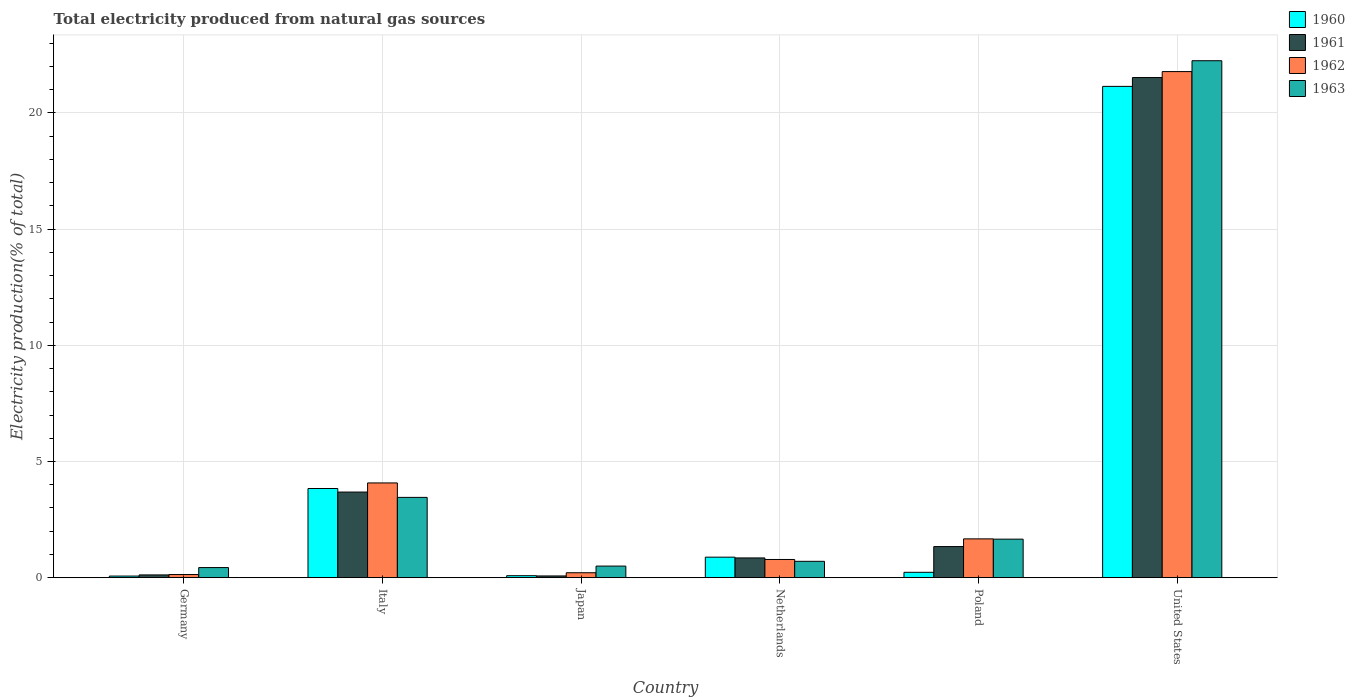How many different coloured bars are there?
Your answer should be compact. 4. Are the number of bars per tick equal to the number of legend labels?
Provide a short and direct response. Yes. Are the number of bars on each tick of the X-axis equal?
Offer a very short reply. Yes. How many bars are there on the 4th tick from the right?
Offer a very short reply. 4. In how many cases, is the number of bars for a given country not equal to the number of legend labels?
Your answer should be compact. 0. What is the total electricity produced in 1961 in Netherlands?
Offer a terse response. 0.85. Across all countries, what is the maximum total electricity produced in 1961?
Your answer should be compact. 21.52. Across all countries, what is the minimum total electricity produced in 1962?
Provide a succinct answer. 0.14. What is the total total electricity produced in 1960 in the graph?
Offer a very short reply. 26.25. What is the difference between the total electricity produced in 1962 in Italy and that in United States?
Ensure brevity in your answer.  -17.7. What is the difference between the total electricity produced in 1960 in Netherlands and the total electricity produced in 1961 in Japan?
Ensure brevity in your answer.  0.81. What is the average total electricity produced in 1963 per country?
Your answer should be compact. 4.83. What is the difference between the total electricity produced of/in 1962 and total electricity produced of/in 1961 in Italy?
Your answer should be compact. 0.39. What is the ratio of the total electricity produced in 1961 in Netherlands to that in Poland?
Offer a terse response. 0.64. Is the total electricity produced in 1963 in Japan less than that in United States?
Make the answer very short. Yes. Is the difference between the total electricity produced in 1962 in Germany and Poland greater than the difference between the total electricity produced in 1961 in Germany and Poland?
Your response must be concise. No. What is the difference between the highest and the second highest total electricity produced in 1962?
Ensure brevity in your answer.  -2.41. What is the difference between the highest and the lowest total electricity produced in 1960?
Your response must be concise. 21.07. What does the 3rd bar from the right in Italy represents?
Make the answer very short. 1961. Is it the case that in every country, the sum of the total electricity produced in 1963 and total electricity produced in 1962 is greater than the total electricity produced in 1961?
Provide a short and direct response. Yes. How many bars are there?
Give a very brief answer. 24. Does the graph contain any zero values?
Offer a terse response. No. How are the legend labels stacked?
Provide a succinct answer. Vertical. What is the title of the graph?
Provide a short and direct response. Total electricity produced from natural gas sources. What is the label or title of the X-axis?
Make the answer very short. Country. What is the label or title of the Y-axis?
Your response must be concise. Electricity production(% of total). What is the Electricity production(% of total) of 1960 in Germany?
Provide a short and direct response. 0.07. What is the Electricity production(% of total) in 1961 in Germany?
Provide a short and direct response. 0.12. What is the Electricity production(% of total) in 1962 in Germany?
Ensure brevity in your answer.  0.14. What is the Electricity production(% of total) in 1963 in Germany?
Your answer should be very brief. 0.44. What is the Electricity production(% of total) of 1960 in Italy?
Offer a very short reply. 3.84. What is the Electricity production(% of total) in 1961 in Italy?
Provide a succinct answer. 3.69. What is the Electricity production(% of total) in 1962 in Italy?
Provide a succinct answer. 4.08. What is the Electricity production(% of total) in 1963 in Italy?
Ensure brevity in your answer.  3.46. What is the Electricity production(% of total) in 1960 in Japan?
Provide a short and direct response. 0.09. What is the Electricity production(% of total) of 1961 in Japan?
Ensure brevity in your answer.  0.08. What is the Electricity production(% of total) in 1962 in Japan?
Your response must be concise. 0.21. What is the Electricity production(% of total) in 1963 in Japan?
Keep it short and to the point. 0.5. What is the Electricity production(% of total) of 1960 in Netherlands?
Make the answer very short. 0.88. What is the Electricity production(% of total) of 1961 in Netherlands?
Your answer should be compact. 0.85. What is the Electricity production(% of total) of 1962 in Netherlands?
Offer a terse response. 0.78. What is the Electricity production(% of total) of 1963 in Netherlands?
Keep it short and to the point. 0.71. What is the Electricity production(% of total) in 1960 in Poland?
Give a very brief answer. 0.23. What is the Electricity production(% of total) in 1961 in Poland?
Provide a succinct answer. 1.34. What is the Electricity production(% of total) of 1962 in Poland?
Offer a very short reply. 1.67. What is the Electricity production(% of total) of 1963 in Poland?
Your response must be concise. 1.66. What is the Electricity production(% of total) in 1960 in United States?
Give a very brief answer. 21.14. What is the Electricity production(% of total) of 1961 in United States?
Your answer should be very brief. 21.52. What is the Electricity production(% of total) in 1962 in United States?
Keep it short and to the point. 21.78. What is the Electricity production(% of total) in 1963 in United States?
Offer a terse response. 22.24. Across all countries, what is the maximum Electricity production(% of total) in 1960?
Your answer should be compact. 21.14. Across all countries, what is the maximum Electricity production(% of total) of 1961?
Offer a terse response. 21.52. Across all countries, what is the maximum Electricity production(% of total) of 1962?
Provide a succinct answer. 21.78. Across all countries, what is the maximum Electricity production(% of total) of 1963?
Ensure brevity in your answer.  22.24. Across all countries, what is the minimum Electricity production(% of total) in 1960?
Make the answer very short. 0.07. Across all countries, what is the minimum Electricity production(% of total) of 1961?
Give a very brief answer. 0.08. Across all countries, what is the minimum Electricity production(% of total) in 1962?
Provide a short and direct response. 0.14. Across all countries, what is the minimum Electricity production(% of total) in 1963?
Your response must be concise. 0.44. What is the total Electricity production(% of total) of 1960 in the graph?
Your answer should be very brief. 26.25. What is the total Electricity production(% of total) of 1961 in the graph?
Your response must be concise. 27.59. What is the total Electricity production(% of total) in 1962 in the graph?
Ensure brevity in your answer.  28.66. What is the total Electricity production(% of total) in 1963 in the graph?
Give a very brief answer. 29. What is the difference between the Electricity production(% of total) in 1960 in Germany and that in Italy?
Ensure brevity in your answer.  -3.77. What is the difference between the Electricity production(% of total) of 1961 in Germany and that in Italy?
Your response must be concise. -3.57. What is the difference between the Electricity production(% of total) in 1962 in Germany and that in Italy?
Keep it short and to the point. -3.94. What is the difference between the Electricity production(% of total) of 1963 in Germany and that in Italy?
Provide a succinct answer. -3.02. What is the difference between the Electricity production(% of total) in 1960 in Germany and that in Japan?
Your answer should be very brief. -0.02. What is the difference between the Electricity production(% of total) in 1961 in Germany and that in Japan?
Your answer should be very brief. 0.04. What is the difference between the Electricity production(% of total) in 1962 in Germany and that in Japan?
Keep it short and to the point. -0.08. What is the difference between the Electricity production(% of total) in 1963 in Germany and that in Japan?
Your answer should be very brief. -0.06. What is the difference between the Electricity production(% of total) of 1960 in Germany and that in Netherlands?
Your answer should be compact. -0.81. What is the difference between the Electricity production(% of total) of 1961 in Germany and that in Netherlands?
Your response must be concise. -0.73. What is the difference between the Electricity production(% of total) of 1962 in Germany and that in Netherlands?
Ensure brevity in your answer.  -0.65. What is the difference between the Electricity production(% of total) of 1963 in Germany and that in Netherlands?
Give a very brief answer. -0.27. What is the difference between the Electricity production(% of total) of 1960 in Germany and that in Poland?
Keep it short and to the point. -0.16. What is the difference between the Electricity production(% of total) in 1961 in Germany and that in Poland?
Provide a succinct answer. -1.22. What is the difference between the Electricity production(% of total) of 1962 in Germany and that in Poland?
Make the answer very short. -1.53. What is the difference between the Electricity production(% of total) of 1963 in Germany and that in Poland?
Give a very brief answer. -1.22. What is the difference between the Electricity production(% of total) in 1960 in Germany and that in United States?
Your answer should be very brief. -21.07. What is the difference between the Electricity production(% of total) of 1961 in Germany and that in United States?
Your response must be concise. -21.4. What is the difference between the Electricity production(% of total) in 1962 in Germany and that in United States?
Ensure brevity in your answer.  -21.64. What is the difference between the Electricity production(% of total) in 1963 in Germany and that in United States?
Offer a very short reply. -21.81. What is the difference between the Electricity production(% of total) in 1960 in Italy and that in Japan?
Your answer should be very brief. 3.75. What is the difference between the Electricity production(% of total) in 1961 in Italy and that in Japan?
Provide a succinct answer. 3.61. What is the difference between the Electricity production(% of total) of 1962 in Italy and that in Japan?
Keep it short and to the point. 3.86. What is the difference between the Electricity production(% of total) in 1963 in Italy and that in Japan?
Your response must be concise. 2.96. What is the difference between the Electricity production(% of total) of 1960 in Italy and that in Netherlands?
Ensure brevity in your answer.  2.95. What is the difference between the Electricity production(% of total) in 1961 in Italy and that in Netherlands?
Your answer should be compact. 2.83. What is the difference between the Electricity production(% of total) in 1962 in Italy and that in Netherlands?
Your answer should be very brief. 3.29. What is the difference between the Electricity production(% of total) of 1963 in Italy and that in Netherlands?
Your answer should be compact. 2.75. What is the difference between the Electricity production(% of total) of 1960 in Italy and that in Poland?
Provide a short and direct response. 3.61. What is the difference between the Electricity production(% of total) in 1961 in Italy and that in Poland?
Give a very brief answer. 2.35. What is the difference between the Electricity production(% of total) in 1962 in Italy and that in Poland?
Your answer should be compact. 2.41. What is the difference between the Electricity production(% of total) of 1963 in Italy and that in Poland?
Your response must be concise. 1.8. What is the difference between the Electricity production(% of total) of 1960 in Italy and that in United States?
Keep it short and to the point. -17.3. What is the difference between the Electricity production(% of total) in 1961 in Italy and that in United States?
Your response must be concise. -17.84. What is the difference between the Electricity production(% of total) in 1962 in Italy and that in United States?
Offer a terse response. -17.7. What is the difference between the Electricity production(% of total) in 1963 in Italy and that in United States?
Offer a very short reply. -18.79. What is the difference between the Electricity production(% of total) in 1960 in Japan and that in Netherlands?
Provide a short and direct response. -0.8. What is the difference between the Electricity production(% of total) in 1961 in Japan and that in Netherlands?
Provide a short and direct response. -0.78. What is the difference between the Electricity production(% of total) in 1962 in Japan and that in Netherlands?
Provide a succinct answer. -0.57. What is the difference between the Electricity production(% of total) in 1963 in Japan and that in Netherlands?
Make the answer very short. -0.21. What is the difference between the Electricity production(% of total) in 1960 in Japan and that in Poland?
Keep it short and to the point. -0.15. What is the difference between the Electricity production(% of total) in 1961 in Japan and that in Poland?
Provide a succinct answer. -1.26. What is the difference between the Electricity production(% of total) of 1962 in Japan and that in Poland?
Your response must be concise. -1.46. What is the difference between the Electricity production(% of total) of 1963 in Japan and that in Poland?
Your answer should be very brief. -1.16. What is the difference between the Electricity production(% of total) in 1960 in Japan and that in United States?
Keep it short and to the point. -21.05. What is the difference between the Electricity production(% of total) in 1961 in Japan and that in United States?
Ensure brevity in your answer.  -21.45. What is the difference between the Electricity production(% of total) of 1962 in Japan and that in United States?
Provide a succinct answer. -21.56. What is the difference between the Electricity production(% of total) in 1963 in Japan and that in United States?
Offer a very short reply. -21.74. What is the difference between the Electricity production(% of total) of 1960 in Netherlands and that in Poland?
Ensure brevity in your answer.  0.65. What is the difference between the Electricity production(% of total) of 1961 in Netherlands and that in Poland?
Offer a terse response. -0.49. What is the difference between the Electricity production(% of total) of 1962 in Netherlands and that in Poland?
Offer a terse response. -0.89. What is the difference between the Electricity production(% of total) of 1963 in Netherlands and that in Poland?
Provide a succinct answer. -0.95. What is the difference between the Electricity production(% of total) of 1960 in Netherlands and that in United States?
Provide a succinct answer. -20.26. What is the difference between the Electricity production(% of total) in 1961 in Netherlands and that in United States?
Provide a succinct answer. -20.67. What is the difference between the Electricity production(% of total) of 1962 in Netherlands and that in United States?
Ensure brevity in your answer.  -20.99. What is the difference between the Electricity production(% of total) in 1963 in Netherlands and that in United States?
Offer a terse response. -21.54. What is the difference between the Electricity production(% of total) in 1960 in Poland and that in United States?
Offer a terse response. -20.91. What is the difference between the Electricity production(% of total) of 1961 in Poland and that in United States?
Give a very brief answer. -20.18. What is the difference between the Electricity production(% of total) of 1962 in Poland and that in United States?
Offer a very short reply. -20.11. What is the difference between the Electricity production(% of total) of 1963 in Poland and that in United States?
Your answer should be compact. -20.59. What is the difference between the Electricity production(% of total) of 1960 in Germany and the Electricity production(% of total) of 1961 in Italy?
Your response must be concise. -3.62. What is the difference between the Electricity production(% of total) of 1960 in Germany and the Electricity production(% of total) of 1962 in Italy?
Offer a very short reply. -4.01. What is the difference between the Electricity production(% of total) in 1960 in Germany and the Electricity production(% of total) in 1963 in Italy?
Your answer should be very brief. -3.39. What is the difference between the Electricity production(% of total) in 1961 in Germany and the Electricity production(% of total) in 1962 in Italy?
Offer a very short reply. -3.96. What is the difference between the Electricity production(% of total) of 1961 in Germany and the Electricity production(% of total) of 1963 in Italy?
Ensure brevity in your answer.  -3.34. What is the difference between the Electricity production(% of total) in 1962 in Germany and the Electricity production(% of total) in 1963 in Italy?
Keep it short and to the point. -3.32. What is the difference between the Electricity production(% of total) in 1960 in Germany and the Electricity production(% of total) in 1961 in Japan?
Ensure brevity in your answer.  -0.01. What is the difference between the Electricity production(% of total) of 1960 in Germany and the Electricity production(% of total) of 1962 in Japan?
Keep it short and to the point. -0.14. What is the difference between the Electricity production(% of total) of 1960 in Germany and the Electricity production(% of total) of 1963 in Japan?
Keep it short and to the point. -0.43. What is the difference between the Electricity production(% of total) in 1961 in Germany and the Electricity production(% of total) in 1962 in Japan?
Give a very brief answer. -0.09. What is the difference between the Electricity production(% of total) of 1961 in Germany and the Electricity production(% of total) of 1963 in Japan?
Offer a terse response. -0.38. What is the difference between the Electricity production(% of total) of 1962 in Germany and the Electricity production(% of total) of 1963 in Japan?
Keep it short and to the point. -0.36. What is the difference between the Electricity production(% of total) in 1960 in Germany and the Electricity production(% of total) in 1961 in Netherlands?
Ensure brevity in your answer.  -0.78. What is the difference between the Electricity production(% of total) in 1960 in Germany and the Electricity production(% of total) in 1962 in Netherlands?
Offer a terse response. -0.71. What is the difference between the Electricity production(% of total) in 1960 in Germany and the Electricity production(% of total) in 1963 in Netherlands?
Offer a terse response. -0.64. What is the difference between the Electricity production(% of total) of 1961 in Germany and the Electricity production(% of total) of 1962 in Netherlands?
Give a very brief answer. -0.66. What is the difference between the Electricity production(% of total) in 1961 in Germany and the Electricity production(% of total) in 1963 in Netherlands?
Your answer should be compact. -0.58. What is the difference between the Electricity production(% of total) in 1962 in Germany and the Electricity production(% of total) in 1963 in Netherlands?
Ensure brevity in your answer.  -0.57. What is the difference between the Electricity production(% of total) of 1960 in Germany and the Electricity production(% of total) of 1961 in Poland?
Provide a succinct answer. -1.27. What is the difference between the Electricity production(% of total) of 1960 in Germany and the Electricity production(% of total) of 1962 in Poland?
Your answer should be compact. -1.6. What is the difference between the Electricity production(% of total) of 1960 in Germany and the Electricity production(% of total) of 1963 in Poland?
Make the answer very short. -1.59. What is the difference between the Electricity production(% of total) in 1961 in Germany and the Electricity production(% of total) in 1962 in Poland?
Ensure brevity in your answer.  -1.55. What is the difference between the Electricity production(% of total) of 1961 in Germany and the Electricity production(% of total) of 1963 in Poland?
Offer a terse response. -1.54. What is the difference between the Electricity production(% of total) of 1962 in Germany and the Electricity production(% of total) of 1963 in Poland?
Your response must be concise. -1.52. What is the difference between the Electricity production(% of total) of 1960 in Germany and the Electricity production(% of total) of 1961 in United States?
Your answer should be compact. -21.45. What is the difference between the Electricity production(% of total) in 1960 in Germany and the Electricity production(% of total) in 1962 in United States?
Your answer should be very brief. -21.71. What is the difference between the Electricity production(% of total) of 1960 in Germany and the Electricity production(% of total) of 1963 in United States?
Keep it short and to the point. -22.17. What is the difference between the Electricity production(% of total) in 1961 in Germany and the Electricity production(% of total) in 1962 in United States?
Your answer should be very brief. -21.66. What is the difference between the Electricity production(% of total) of 1961 in Germany and the Electricity production(% of total) of 1963 in United States?
Give a very brief answer. -22.12. What is the difference between the Electricity production(% of total) in 1962 in Germany and the Electricity production(% of total) in 1963 in United States?
Keep it short and to the point. -22.11. What is the difference between the Electricity production(% of total) in 1960 in Italy and the Electricity production(% of total) in 1961 in Japan?
Keep it short and to the point. 3.76. What is the difference between the Electricity production(% of total) of 1960 in Italy and the Electricity production(% of total) of 1962 in Japan?
Give a very brief answer. 3.62. What is the difference between the Electricity production(% of total) of 1960 in Italy and the Electricity production(% of total) of 1963 in Japan?
Ensure brevity in your answer.  3.34. What is the difference between the Electricity production(% of total) of 1961 in Italy and the Electricity production(% of total) of 1962 in Japan?
Your response must be concise. 3.47. What is the difference between the Electricity production(% of total) of 1961 in Italy and the Electricity production(% of total) of 1963 in Japan?
Provide a short and direct response. 3.19. What is the difference between the Electricity production(% of total) of 1962 in Italy and the Electricity production(% of total) of 1963 in Japan?
Offer a terse response. 3.58. What is the difference between the Electricity production(% of total) in 1960 in Italy and the Electricity production(% of total) in 1961 in Netherlands?
Keep it short and to the point. 2.99. What is the difference between the Electricity production(% of total) of 1960 in Italy and the Electricity production(% of total) of 1962 in Netherlands?
Your answer should be very brief. 3.05. What is the difference between the Electricity production(% of total) of 1960 in Italy and the Electricity production(% of total) of 1963 in Netherlands?
Make the answer very short. 3.13. What is the difference between the Electricity production(% of total) of 1961 in Italy and the Electricity production(% of total) of 1962 in Netherlands?
Keep it short and to the point. 2.9. What is the difference between the Electricity production(% of total) of 1961 in Italy and the Electricity production(% of total) of 1963 in Netherlands?
Your response must be concise. 2.98. What is the difference between the Electricity production(% of total) in 1962 in Italy and the Electricity production(% of total) in 1963 in Netherlands?
Provide a short and direct response. 3.37. What is the difference between the Electricity production(% of total) of 1960 in Italy and the Electricity production(% of total) of 1961 in Poland?
Your answer should be compact. 2.5. What is the difference between the Electricity production(% of total) in 1960 in Italy and the Electricity production(% of total) in 1962 in Poland?
Make the answer very short. 2.17. What is the difference between the Electricity production(% of total) of 1960 in Italy and the Electricity production(% of total) of 1963 in Poland?
Your answer should be very brief. 2.18. What is the difference between the Electricity production(% of total) in 1961 in Italy and the Electricity production(% of total) in 1962 in Poland?
Ensure brevity in your answer.  2.01. What is the difference between the Electricity production(% of total) of 1961 in Italy and the Electricity production(% of total) of 1963 in Poland?
Offer a very short reply. 2.03. What is the difference between the Electricity production(% of total) in 1962 in Italy and the Electricity production(% of total) in 1963 in Poland?
Offer a terse response. 2.42. What is the difference between the Electricity production(% of total) of 1960 in Italy and the Electricity production(% of total) of 1961 in United States?
Your answer should be compact. -17.68. What is the difference between the Electricity production(% of total) of 1960 in Italy and the Electricity production(% of total) of 1962 in United States?
Your answer should be compact. -17.94. What is the difference between the Electricity production(% of total) of 1960 in Italy and the Electricity production(% of total) of 1963 in United States?
Your response must be concise. -18.41. What is the difference between the Electricity production(% of total) of 1961 in Italy and the Electricity production(% of total) of 1962 in United States?
Your answer should be compact. -18.09. What is the difference between the Electricity production(% of total) in 1961 in Italy and the Electricity production(% of total) in 1963 in United States?
Offer a terse response. -18.56. What is the difference between the Electricity production(% of total) of 1962 in Italy and the Electricity production(% of total) of 1963 in United States?
Your answer should be very brief. -18.17. What is the difference between the Electricity production(% of total) of 1960 in Japan and the Electricity production(% of total) of 1961 in Netherlands?
Offer a terse response. -0.76. What is the difference between the Electricity production(% of total) in 1960 in Japan and the Electricity production(% of total) in 1962 in Netherlands?
Your answer should be compact. -0.7. What is the difference between the Electricity production(% of total) in 1960 in Japan and the Electricity production(% of total) in 1963 in Netherlands?
Provide a succinct answer. -0.62. What is the difference between the Electricity production(% of total) of 1961 in Japan and the Electricity production(% of total) of 1962 in Netherlands?
Your response must be concise. -0.71. What is the difference between the Electricity production(% of total) in 1961 in Japan and the Electricity production(% of total) in 1963 in Netherlands?
Keep it short and to the point. -0.63. What is the difference between the Electricity production(% of total) of 1962 in Japan and the Electricity production(% of total) of 1963 in Netherlands?
Provide a short and direct response. -0.49. What is the difference between the Electricity production(% of total) in 1960 in Japan and the Electricity production(% of total) in 1961 in Poland?
Make the answer very short. -1.25. What is the difference between the Electricity production(% of total) in 1960 in Japan and the Electricity production(% of total) in 1962 in Poland?
Your response must be concise. -1.58. What is the difference between the Electricity production(% of total) in 1960 in Japan and the Electricity production(% of total) in 1963 in Poland?
Your answer should be very brief. -1.57. What is the difference between the Electricity production(% of total) of 1961 in Japan and the Electricity production(% of total) of 1962 in Poland?
Keep it short and to the point. -1.6. What is the difference between the Electricity production(% of total) of 1961 in Japan and the Electricity production(% of total) of 1963 in Poland?
Give a very brief answer. -1.58. What is the difference between the Electricity production(% of total) of 1962 in Japan and the Electricity production(% of total) of 1963 in Poland?
Your response must be concise. -1.45. What is the difference between the Electricity production(% of total) of 1960 in Japan and the Electricity production(% of total) of 1961 in United States?
Your answer should be very brief. -21.43. What is the difference between the Electricity production(% of total) of 1960 in Japan and the Electricity production(% of total) of 1962 in United States?
Keep it short and to the point. -21.69. What is the difference between the Electricity production(% of total) in 1960 in Japan and the Electricity production(% of total) in 1963 in United States?
Provide a succinct answer. -22.16. What is the difference between the Electricity production(% of total) of 1961 in Japan and the Electricity production(% of total) of 1962 in United States?
Make the answer very short. -21.7. What is the difference between the Electricity production(% of total) in 1961 in Japan and the Electricity production(% of total) in 1963 in United States?
Your answer should be compact. -22.17. What is the difference between the Electricity production(% of total) of 1962 in Japan and the Electricity production(% of total) of 1963 in United States?
Ensure brevity in your answer.  -22.03. What is the difference between the Electricity production(% of total) of 1960 in Netherlands and the Electricity production(% of total) of 1961 in Poland?
Offer a very short reply. -0.46. What is the difference between the Electricity production(% of total) in 1960 in Netherlands and the Electricity production(% of total) in 1962 in Poland?
Keep it short and to the point. -0.79. What is the difference between the Electricity production(% of total) in 1960 in Netherlands and the Electricity production(% of total) in 1963 in Poland?
Your answer should be very brief. -0.78. What is the difference between the Electricity production(% of total) of 1961 in Netherlands and the Electricity production(% of total) of 1962 in Poland?
Keep it short and to the point. -0.82. What is the difference between the Electricity production(% of total) of 1961 in Netherlands and the Electricity production(% of total) of 1963 in Poland?
Ensure brevity in your answer.  -0.81. What is the difference between the Electricity production(% of total) in 1962 in Netherlands and the Electricity production(% of total) in 1963 in Poland?
Provide a succinct answer. -0.88. What is the difference between the Electricity production(% of total) in 1960 in Netherlands and the Electricity production(% of total) in 1961 in United States?
Give a very brief answer. -20.64. What is the difference between the Electricity production(% of total) in 1960 in Netherlands and the Electricity production(% of total) in 1962 in United States?
Your answer should be very brief. -20.89. What is the difference between the Electricity production(% of total) of 1960 in Netherlands and the Electricity production(% of total) of 1963 in United States?
Make the answer very short. -21.36. What is the difference between the Electricity production(% of total) of 1961 in Netherlands and the Electricity production(% of total) of 1962 in United States?
Your response must be concise. -20.93. What is the difference between the Electricity production(% of total) in 1961 in Netherlands and the Electricity production(% of total) in 1963 in United States?
Offer a terse response. -21.39. What is the difference between the Electricity production(% of total) in 1962 in Netherlands and the Electricity production(% of total) in 1963 in United States?
Provide a succinct answer. -21.46. What is the difference between the Electricity production(% of total) of 1960 in Poland and the Electricity production(% of total) of 1961 in United States?
Offer a very short reply. -21.29. What is the difference between the Electricity production(% of total) in 1960 in Poland and the Electricity production(% of total) in 1962 in United States?
Give a very brief answer. -21.55. What is the difference between the Electricity production(% of total) of 1960 in Poland and the Electricity production(% of total) of 1963 in United States?
Your response must be concise. -22.01. What is the difference between the Electricity production(% of total) in 1961 in Poland and the Electricity production(% of total) in 1962 in United States?
Offer a terse response. -20.44. What is the difference between the Electricity production(% of total) in 1961 in Poland and the Electricity production(% of total) in 1963 in United States?
Your answer should be very brief. -20.91. What is the difference between the Electricity production(% of total) of 1962 in Poland and the Electricity production(% of total) of 1963 in United States?
Give a very brief answer. -20.57. What is the average Electricity production(% of total) in 1960 per country?
Offer a very short reply. 4.38. What is the average Electricity production(% of total) of 1961 per country?
Your answer should be very brief. 4.6. What is the average Electricity production(% of total) of 1962 per country?
Your answer should be very brief. 4.78. What is the average Electricity production(% of total) of 1963 per country?
Your answer should be very brief. 4.83. What is the difference between the Electricity production(% of total) in 1960 and Electricity production(% of total) in 1962 in Germany?
Your answer should be very brief. -0.07. What is the difference between the Electricity production(% of total) in 1960 and Electricity production(% of total) in 1963 in Germany?
Give a very brief answer. -0.37. What is the difference between the Electricity production(% of total) of 1961 and Electricity production(% of total) of 1962 in Germany?
Your response must be concise. -0.02. What is the difference between the Electricity production(% of total) in 1961 and Electricity production(% of total) in 1963 in Germany?
Provide a succinct answer. -0.32. What is the difference between the Electricity production(% of total) in 1962 and Electricity production(% of total) in 1963 in Germany?
Keep it short and to the point. -0.3. What is the difference between the Electricity production(% of total) of 1960 and Electricity production(% of total) of 1961 in Italy?
Offer a very short reply. 0.15. What is the difference between the Electricity production(% of total) of 1960 and Electricity production(% of total) of 1962 in Italy?
Provide a succinct answer. -0.24. What is the difference between the Electricity production(% of total) in 1960 and Electricity production(% of total) in 1963 in Italy?
Your response must be concise. 0.38. What is the difference between the Electricity production(% of total) in 1961 and Electricity production(% of total) in 1962 in Italy?
Give a very brief answer. -0.39. What is the difference between the Electricity production(% of total) of 1961 and Electricity production(% of total) of 1963 in Italy?
Make the answer very short. 0.23. What is the difference between the Electricity production(% of total) in 1962 and Electricity production(% of total) in 1963 in Italy?
Ensure brevity in your answer.  0.62. What is the difference between the Electricity production(% of total) of 1960 and Electricity production(% of total) of 1961 in Japan?
Offer a terse response. 0.01. What is the difference between the Electricity production(% of total) in 1960 and Electricity production(% of total) in 1962 in Japan?
Make the answer very short. -0.13. What is the difference between the Electricity production(% of total) of 1960 and Electricity production(% of total) of 1963 in Japan?
Ensure brevity in your answer.  -0.41. What is the difference between the Electricity production(% of total) in 1961 and Electricity production(% of total) in 1962 in Japan?
Give a very brief answer. -0.14. What is the difference between the Electricity production(% of total) of 1961 and Electricity production(% of total) of 1963 in Japan?
Offer a terse response. -0.42. What is the difference between the Electricity production(% of total) of 1962 and Electricity production(% of total) of 1963 in Japan?
Your answer should be compact. -0.29. What is the difference between the Electricity production(% of total) in 1960 and Electricity production(% of total) in 1961 in Netherlands?
Offer a very short reply. 0.03. What is the difference between the Electricity production(% of total) in 1960 and Electricity production(% of total) in 1962 in Netherlands?
Provide a short and direct response. 0.1. What is the difference between the Electricity production(% of total) in 1960 and Electricity production(% of total) in 1963 in Netherlands?
Your answer should be very brief. 0.18. What is the difference between the Electricity production(% of total) of 1961 and Electricity production(% of total) of 1962 in Netherlands?
Give a very brief answer. 0.07. What is the difference between the Electricity production(% of total) of 1961 and Electricity production(% of total) of 1963 in Netherlands?
Your answer should be very brief. 0.15. What is the difference between the Electricity production(% of total) of 1962 and Electricity production(% of total) of 1963 in Netherlands?
Make the answer very short. 0.08. What is the difference between the Electricity production(% of total) in 1960 and Electricity production(% of total) in 1961 in Poland?
Keep it short and to the point. -1.11. What is the difference between the Electricity production(% of total) of 1960 and Electricity production(% of total) of 1962 in Poland?
Keep it short and to the point. -1.44. What is the difference between the Electricity production(% of total) of 1960 and Electricity production(% of total) of 1963 in Poland?
Your answer should be compact. -1.43. What is the difference between the Electricity production(% of total) of 1961 and Electricity production(% of total) of 1962 in Poland?
Your answer should be compact. -0.33. What is the difference between the Electricity production(% of total) of 1961 and Electricity production(% of total) of 1963 in Poland?
Provide a succinct answer. -0.32. What is the difference between the Electricity production(% of total) of 1962 and Electricity production(% of total) of 1963 in Poland?
Provide a short and direct response. 0.01. What is the difference between the Electricity production(% of total) in 1960 and Electricity production(% of total) in 1961 in United States?
Provide a succinct answer. -0.38. What is the difference between the Electricity production(% of total) in 1960 and Electricity production(% of total) in 1962 in United States?
Offer a very short reply. -0.64. What is the difference between the Electricity production(% of total) of 1960 and Electricity production(% of total) of 1963 in United States?
Provide a succinct answer. -1.1. What is the difference between the Electricity production(% of total) in 1961 and Electricity production(% of total) in 1962 in United States?
Provide a short and direct response. -0.26. What is the difference between the Electricity production(% of total) in 1961 and Electricity production(% of total) in 1963 in United States?
Provide a succinct answer. -0.72. What is the difference between the Electricity production(% of total) of 1962 and Electricity production(% of total) of 1963 in United States?
Your answer should be very brief. -0.47. What is the ratio of the Electricity production(% of total) of 1960 in Germany to that in Italy?
Provide a succinct answer. 0.02. What is the ratio of the Electricity production(% of total) in 1961 in Germany to that in Italy?
Offer a terse response. 0.03. What is the ratio of the Electricity production(% of total) of 1962 in Germany to that in Italy?
Offer a terse response. 0.03. What is the ratio of the Electricity production(% of total) in 1963 in Germany to that in Italy?
Ensure brevity in your answer.  0.13. What is the ratio of the Electricity production(% of total) in 1960 in Germany to that in Japan?
Your answer should be very brief. 0.81. What is the ratio of the Electricity production(% of total) in 1961 in Germany to that in Japan?
Make the answer very short. 1.59. What is the ratio of the Electricity production(% of total) in 1962 in Germany to that in Japan?
Give a very brief answer. 0.64. What is the ratio of the Electricity production(% of total) of 1963 in Germany to that in Japan?
Ensure brevity in your answer.  0.87. What is the ratio of the Electricity production(% of total) of 1960 in Germany to that in Netherlands?
Your answer should be very brief. 0.08. What is the ratio of the Electricity production(% of total) of 1961 in Germany to that in Netherlands?
Provide a short and direct response. 0.14. What is the ratio of the Electricity production(% of total) of 1962 in Germany to that in Netherlands?
Your answer should be very brief. 0.17. What is the ratio of the Electricity production(% of total) in 1963 in Germany to that in Netherlands?
Offer a very short reply. 0.62. What is the ratio of the Electricity production(% of total) of 1960 in Germany to that in Poland?
Ensure brevity in your answer.  0.3. What is the ratio of the Electricity production(% of total) in 1961 in Germany to that in Poland?
Your answer should be very brief. 0.09. What is the ratio of the Electricity production(% of total) of 1962 in Germany to that in Poland?
Offer a very short reply. 0.08. What is the ratio of the Electricity production(% of total) of 1963 in Germany to that in Poland?
Offer a very short reply. 0.26. What is the ratio of the Electricity production(% of total) in 1960 in Germany to that in United States?
Your answer should be compact. 0. What is the ratio of the Electricity production(% of total) in 1961 in Germany to that in United States?
Offer a terse response. 0.01. What is the ratio of the Electricity production(% of total) in 1962 in Germany to that in United States?
Your answer should be very brief. 0.01. What is the ratio of the Electricity production(% of total) of 1963 in Germany to that in United States?
Make the answer very short. 0.02. What is the ratio of the Electricity production(% of total) of 1960 in Italy to that in Japan?
Ensure brevity in your answer.  44.33. What is the ratio of the Electricity production(% of total) in 1961 in Italy to that in Japan?
Keep it short and to the point. 48.69. What is the ratio of the Electricity production(% of total) in 1962 in Italy to that in Japan?
Ensure brevity in your answer.  19.09. What is the ratio of the Electricity production(% of total) in 1963 in Italy to that in Japan?
Give a very brief answer. 6.91. What is the ratio of the Electricity production(% of total) in 1960 in Italy to that in Netherlands?
Ensure brevity in your answer.  4.34. What is the ratio of the Electricity production(% of total) of 1961 in Italy to that in Netherlands?
Offer a very short reply. 4.33. What is the ratio of the Electricity production(% of total) of 1962 in Italy to that in Netherlands?
Make the answer very short. 5.2. What is the ratio of the Electricity production(% of total) of 1963 in Italy to that in Netherlands?
Your response must be concise. 4.9. What is the ratio of the Electricity production(% of total) in 1960 in Italy to that in Poland?
Offer a terse response. 16.53. What is the ratio of the Electricity production(% of total) of 1961 in Italy to that in Poland?
Make the answer very short. 2.75. What is the ratio of the Electricity production(% of total) in 1962 in Italy to that in Poland?
Your response must be concise. 2.44. What is the ratio of the Electricity production(% of total) of 1963 in Italy to that in Poland?
Your answer should be very brief. 2.08. What is the ratio of the Electricity production(% of total) in 1960 in Italy to that in United States?
Make the answer very short. 0.18. What is the ratio of the Electricity production(% of total) in 1961 in Italy to that in United States?
Offer a very short reply. 0.17. What is the ratio of the Electricity production(% of total) of 1962 in Italy to that in United States?
Your answer should be compact. 0.19. What is the ratio of the Electricity production(% of total) in 1963 in Italy to that in United States?
Offer a terse response. 0.16. What is the ratio of the Electricity production(% of total) in 1960 in Japan to that in Netherlands?
Give a very brief answer. 0.1. What is the ratio of the Electricity production(% of total) of 1961 in Japan to that in Netherlands?
Provide a short and direct response. 0.09. What is the ratio of the Electricity production(% of total) in 1962 in Japan to that in Netherlands?
Keep it short and to the point. 0.27. What is the ratio of the Electricity production(% of total) in 1963 in Japan to that in Netherlands?
Make the answer very short. 0.71. What is the ratio of the Electricity production(% of total) of 1960 in Japan to that in Poland?
Offer a very short reply. 0.37. What is the ratio of the Electricity production(% of total) in 1961 in Japan to that in Poland?
Offer a very short reply. 0.06. What is the ratio of the Electricity production(% of total) of 1962 in Japan to that in Poland?
Make the answer very short. 0.13. What is the ratio of the Electricity production(% of total) in 1963 in Japan to that in Poland?
Make the answer very short. 0.3. What is the ratio of the Electricity production(% of total) in 1960 in Japan to that in United States?
Give a very brief answer. 0. What is the ratio of the Electricity production(% of total) of 1961 in Japan to that in United States?
Keep it short and to the point. 0. What is the ratio of the Electricity production(% of total) of 1962 in Japan to that in United States?
Offer a very short reply. 0.01. What is the ratio of the Electricity production(% of total) in 1963 in Japan to that in United States?
Offer a very short reply. 0.02. What is the ratio of the Electricity production(% of total) in 1960 in Netherlands to that in Poland?
Your answer should be compact. 3.81. What is the ratio of the Electricity production(% of total) in 1961 in Netherlands to that in Poland?
Provide a short and direct response. 0.64. What is the ratio of the Electricity production(% of total) in 1962 in Netherlands to that in Poland?
Your answer should be very brief. 0.47. What is the ratio of the Electricity production(% of total) in 1963 in Netherlands to that in Poland?
Make the answer very short. 0.42. What is the ratio of the Electricity production(% of total) of 1960 in Netherlands to that in United States?
Provide a succinct answer. 0.04. What is the ratio of the Electricity production(% of total) of 1961 in Netherlands to that in United States?
Make the answer very short. 0.04. What is the ratio of the Electricity production(% of total) in 1962 in Netherlands to that in United States?
Ensure brevity in your answer.  0.04. What is the ratio of the Electricity production(% of total) of 1963 in Netherlands to that in United States?
Your answer should be compact. 0.03. What is the ratio of the Electricity production(% of total) in 1960 in Poland to that in United States?
Provide a succinct answer. 0.01. What is the ratio of the Electricity production(% of total) in 1961 in Poland to that in United States?
Give a very brief answer. 0.06. What is the ratio of the Electricity production(% of total) in 1962 in Poland to that in United States?
Provide a short and direct response. 0.08. What is the ratio of the Electricity production(% of total) in 1963 in Poland to that in United States?
Ensure brevity in your answer.  0.07. What is the difference between the highest and the second highest Electricity production(% of total) of 1960?
Provide a short and direct response. 17.3. What is the difference between the highest and the second highest Electricity production(% of total) in 1961?
Give a very brief answer. 17.84. What is the difference between the highest and the second highest Electricity production(% of total) of 1962?
Provide a short and direct response. 17.7. What is the difference between the highest and the second highest Electricity production(% of total) in 1963?
Your answer should be compact. 18.79. What is the difference between the highest and the lowest Electricity production(% of total) of 1960?
Provide a short and direct response. 21.07. What is the difference between the highest and the lowest Electricity production(% of total) of 1961?
Make the answer very short. 21.45. What is the difference between the highest and the lowest Electricity production(% of total) in 1962?
Offer a terse response. 21.64. What is the difference between the highest and the lowest Electricity production(% of total) of 1963?
Your answer should be compact. 21.81. 